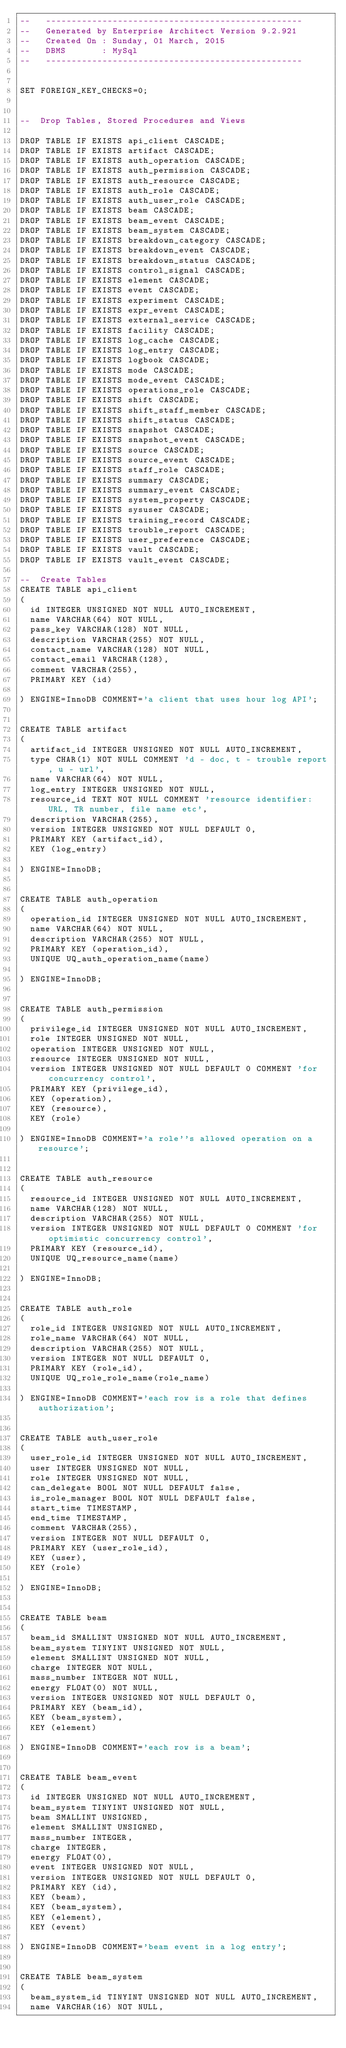Convert code to text. <code><loc_0><loc_0><loc_500><loc_500><_SQL_>--   -------------------------------------------------- 
--   Generated by Enterprise Architect Version 9.2.921
--   Created On : Sunday, 01 March, 2015 
--   DBMS       : MySql 
--   -------------------------------------------------- 


SET FOREIGN_KEY_CHECKS=0;


--  Drop Tables, Stored Procedures and Views 

DROP TABLE IF EXISTS api_client CASCADE;
DROP TABLE IF EXISTS artifact CASCADE;
DROP TABLE IF EXISTS auth_operation CASCADE;
DROP TABLE IF EXISTS auth_permission CASCADE;
DROP TABLE IF EXISTS auth_resource CASCADE;
DROP TABLE IF EXISTS auth_role CASCADE;
DROP TABLE IF EXISTS auth_user_role CASCADE;
DROP TABLE IF EXISTS beam CASCADE;
DROP TABLE IF EXISTS beam_event CASCADE;
DROP TABLE IF EXISTS beam_system CASCADE;
DROP TABLE IF EXISTS breakdown_category CASCADE;
DROP TABLE IF EXISTS breakdown_event CASCADE;
DROP TABLE IF EXISTS breakdown_status CASCADE;
DROP TABLE IF EXISTS control_signal CASCADE;
DROP TABLE IF EXISTS element CASCADE;
DROP TABLE IF EXISTS event CASCADE;
DROP TABLE IF EXISTS experiment CASCADE;
DROP TABLE IF EXISTS expr_event CASCADE;
DROP TABLE IF EXISTS external_service CASCADE;
DROP TABLE IF EXISTS facility CASCADE;
DROP TABLE IF EXISTS log_cache CASCADE;
DROP TABLE IF EXISTS log_entry CASCADE;
DROP TABLE IF EXISTS logbook CASCADE;
DROP TABLE IF EXISTS mode CASCADE;
DROP TABLE IF EXISTS mode_event CASCADE;
DROP TABLE IF EXISTS operations_role CASCADE;
DROP TABLE IF EXISTS shift CASCADE;
DROP TABLE IF EXISTS shift_staff_member CASCADE;
DROP TABLE IF EXISTS shift_status CASCADE;
DROP TABLE IF EXISTS snapshot CASCADE;
DROP TABLE IF EXISTS snapshot_event CASCADE;
DROP TABLE IF EXISTS source CASCADE;
DROP TABLE IF EXISTS source_event CASCADE;
DROP TABLE IF EXISTS staff_role CASCADE;
DROP TABLE IF EXISTS summary CASCADE;
DROP TABLE IF EXISTS summary_event CASCADE;
DROP TABLE IF EXISTS system_property CASCADE;
DROP TABLE IF EXISTS sysuser CASCADE;
DROP TABLE IF EXISTS training_record CASCADE;
DROP TABLE IF EXISTS trouble_report CASCADE;
DROP TABLE IF EXISTS user_preference CASCADE;
DROP TABLE IF EXISTS vault CASCADE;
DROP TABLE IF EXISTS vault_event CASCADE;

--  Create Tables 
CREATE TABLE api_client
(
	id INTEGER UNSIGNED NOT NULL AUTO_INCREMENT,
	name VARCHAR(64) NOT NULL,
	pass_key VARCHAR(128) NOT NULL,
	description VARCHAR(255) NOT NULL,
	contact_name VARCHAR(128) NOT NULL,
	contact_email VARCHAR(128),
	comment VARCHAR(255),
	PRIMARY KEY (id)

) ENGINE=InnoDB COMMENT='a client that uses hour log API';


CREATE TABLE artifact
(
	artifact_id INTEGER UNSIGNED NOT NULL AUTO_INCREMENT,
	type CHAR(1) NOT NULL COMMENT 'd - doc, t - trouble report, u - url',
	name VARCHAR(64) NOT NULL,
	log_entry INTEGER UNSIGNED NOT NULL,
	resource_id TEXT NOT NULL COMMENT 'resource identifier: URL, TR number, file name etc',
	description VARCHAR(255),
	version INTEGER UNSIGNED NOT NULL DEFAULT 0,
	PRIMARY KEY (artifact_id),
	KEY (log_entry)

) ENGINE=InnoDB;


CREATE TABLE auth_operation
(
	operation_id INTEGER UNSIGNED NOT NULL AUTO_INCREMENT,
	name VARCHAR(64) NOT NULL,
	description VARCHAR(255) NOT NULL,
	PRIMARY KEY (operation_id),
	UNIQUE UQ_auth_operation_name(name)

) ENGINE=InnoDB;


CREATE TABLE auth_permission
(
	privilege_id INTEGER UNSIGNED NOT NULL AUTO_INCREMENT,
	role INTEGER UNSIGNED NOT NULL,
	operation INTEGER UNSIGNED NOT NULL,
	resource INTEGER UNSIGNED NOT NULL,
	version INTEGER UNSIGNED NOT NULL DEFAULT 0 COMMENT 'for concurrency control',
	PRIMARY KEY (privilege_id),
	KEY (operation),
	KEY (resource),
	KEY (role)

) ENGINE=InnoDB COMMENT='a role''s allowed operation on a resource';


CREATE TABLE auth_resource
(
	resource_id INTEGER UNSIGNED NOT NULL AUTO_INCREMENT,
	name VARCHAR(128) NOT NULL,
	description VARCHAR(255) NOT NULL,
	version INTEGER UNSIGNED NOT NULL DEFAULT 0 COMMENT 'for optimistic concurrency control',
	PRIMARY KEY (resource_id),
	UNIQUE UQ_resource_name(name)

) ENGINE=InnoDB;


CREATE TABLE auth_role
(
	role_id INTEGER UNSIGNED NOT NULL AUTO_INCREMENT,
	role_name VARCHAR(64) NOT NULL,
	description VARCHAR(255) NOT NULL,
	version INTEGER NOT NULL DEFAULT 0,
	PRIMARY KEY (role_id),
	UNIQUE UQ_role_role_name(role_name)

) ENGINE=InnoDB COMMENT='each row is a role that defines authorization';


CREATE TABLE auth_user_role
(
	user_role_id INTEGER UNSIGNED NOT NULL AUTO_INCREMENT,
	user INTEGER UNSIGNED NOT NULL,
	role INTEGER UNSIGNED NOT NULL,
	can_delegate BOOL NOT NULL DEFAULT false,
	is_role_manager BOOL NOT NULL DEFAULT false,
	start_time TIMESTAMP,
	end_time TIMESTAMP,
	comment VARCHAR(255),
	version INTEGER NOT NULL DEFAULT 0,
	PRIMARY KEY (user_role_id),
	KEY (user),
	KEY (role)

) ENGINE=InnoDB;


CREATE TABLE beam
(
	beam_id SMALLINT UNSIGNED NOT NULL AUTO_INCREMENT,
	beam_system TINYINT UNSIGNED NOT NULL,
	element SMALLINT UNSIGNED NOT NULL,
	charge INTEGER NOT NULL,
	mass_number INTEGER NOT NULL,
	energy FLOAT(0) NOT NULL,
	version INTEGER UNSIGNED NOT NULL DEFAULT 0,
	PRIMARY KEY (beam_id),
	KEY (beam_system),
	KEY (element)

) ENGINE=InnoDB COMMENT='each row is a beam';


CREATE TABLE beam_event
(
	id INTEGER UNSIGNED NOT NULL AUTO_INCREMENT,
	beam_system TINYINT UNSIGNED NOT NULL,
	beam SMALLINT UNSIGNED,
	element SMALLINT UNSIGNED,
	mass_number INTEGER,
	charge INTEGER,
	energy FLOAT(0),
	event INTEGER UNSIGNED NOT NULL,
	version INTEGER UNSIGNED NOT NULL DEFAULT 0,
	PRIMARY KEY (id),
	KEY (beam),
	KEY (beam_system),
	KEY (element),
	KEY (event)

) ENGINE=InnoDB COMMENT='beam event in a log entry';


CREATE TABLE beam_system
(
	beam_system_id TINYINT UNSIGNED NOT NULL AUTO_INCREMENT,
	name VARCHAR(16) NOT NULL,</code> 